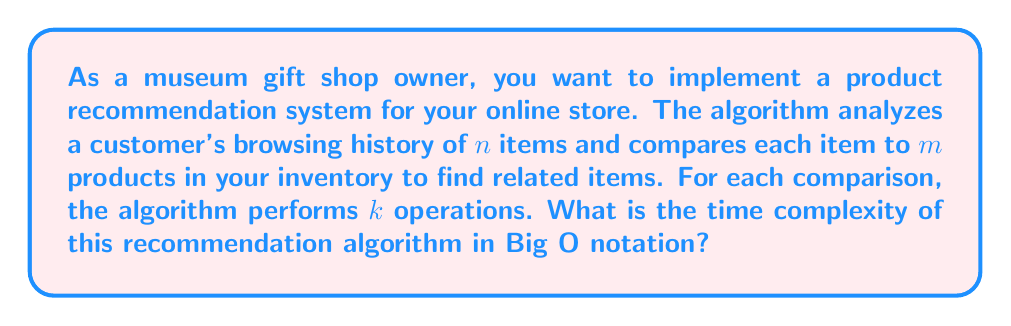Could you help me with this problem? Let's break down the algorithm and analyze its time complexity step by step:

1. The algorithm iterates through each item in the customer's browsing history. There are $n$ items, so this forms our outer loop.

2. For each item in the browsing history, the algorithm compares it to every product in the inventory. There are $m$ products, forming our inner loop.

3. For each comparison between a browsing history item and an inventory product, the algorithm performs $k$ operations.

The structure of the algorithm can be represented as:

```
for each item in browsing_history (n items):
    for each product in inventory (m products):
        perform k operations
```

To calculate the time complexity:

1. The innermost operation is performed $k$ times.
2. This is nested inside two loops:
   - The inner loop runs $m$ times
   - The outer loop runs $n$ times

3. Therefore, the total number of operations is:

   $$n * m * k$$

4. In Big O notation, we focus on the most significant terms and drop constants. Here, $k$ is a constant factor, so we can drop it.

5. The resulting time complexity is:

   $$O(n * m)$$

This is also sometimes written as $O(nm)$.
Answer: $O(nm)$ 